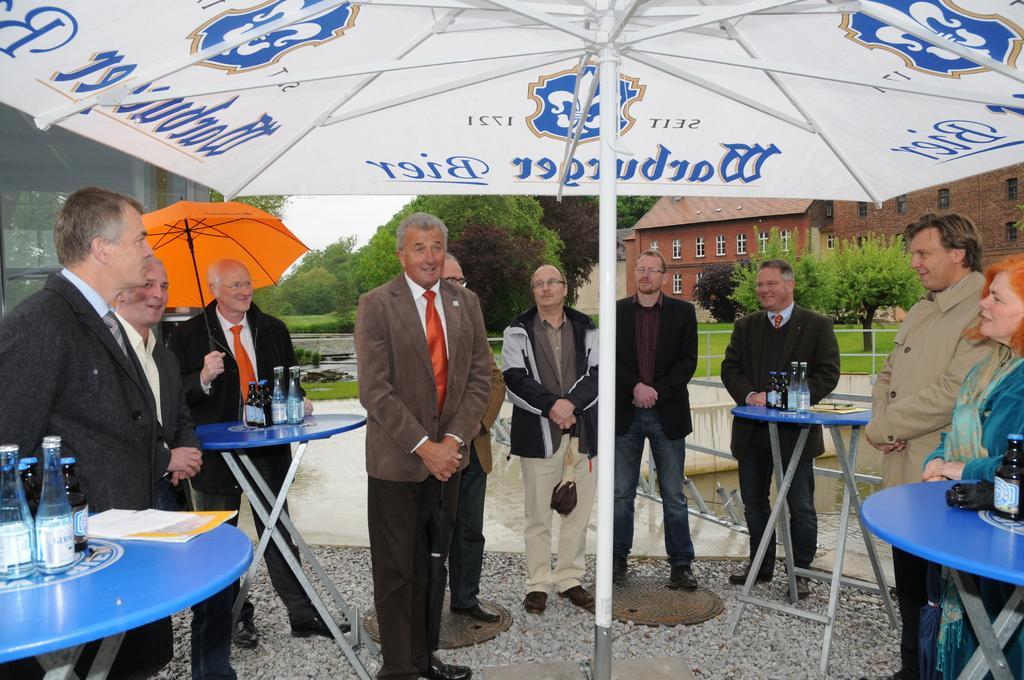In one or two sentences, can you explain what this image depicts? In this image, there are many people standing under the umbrella. To the right the woman is wearing a blue dress. To the left, the man is wearing black suit. In the middle the man is wearing brown suit and red tie. In the background there is a tree, house , windows, grass. 